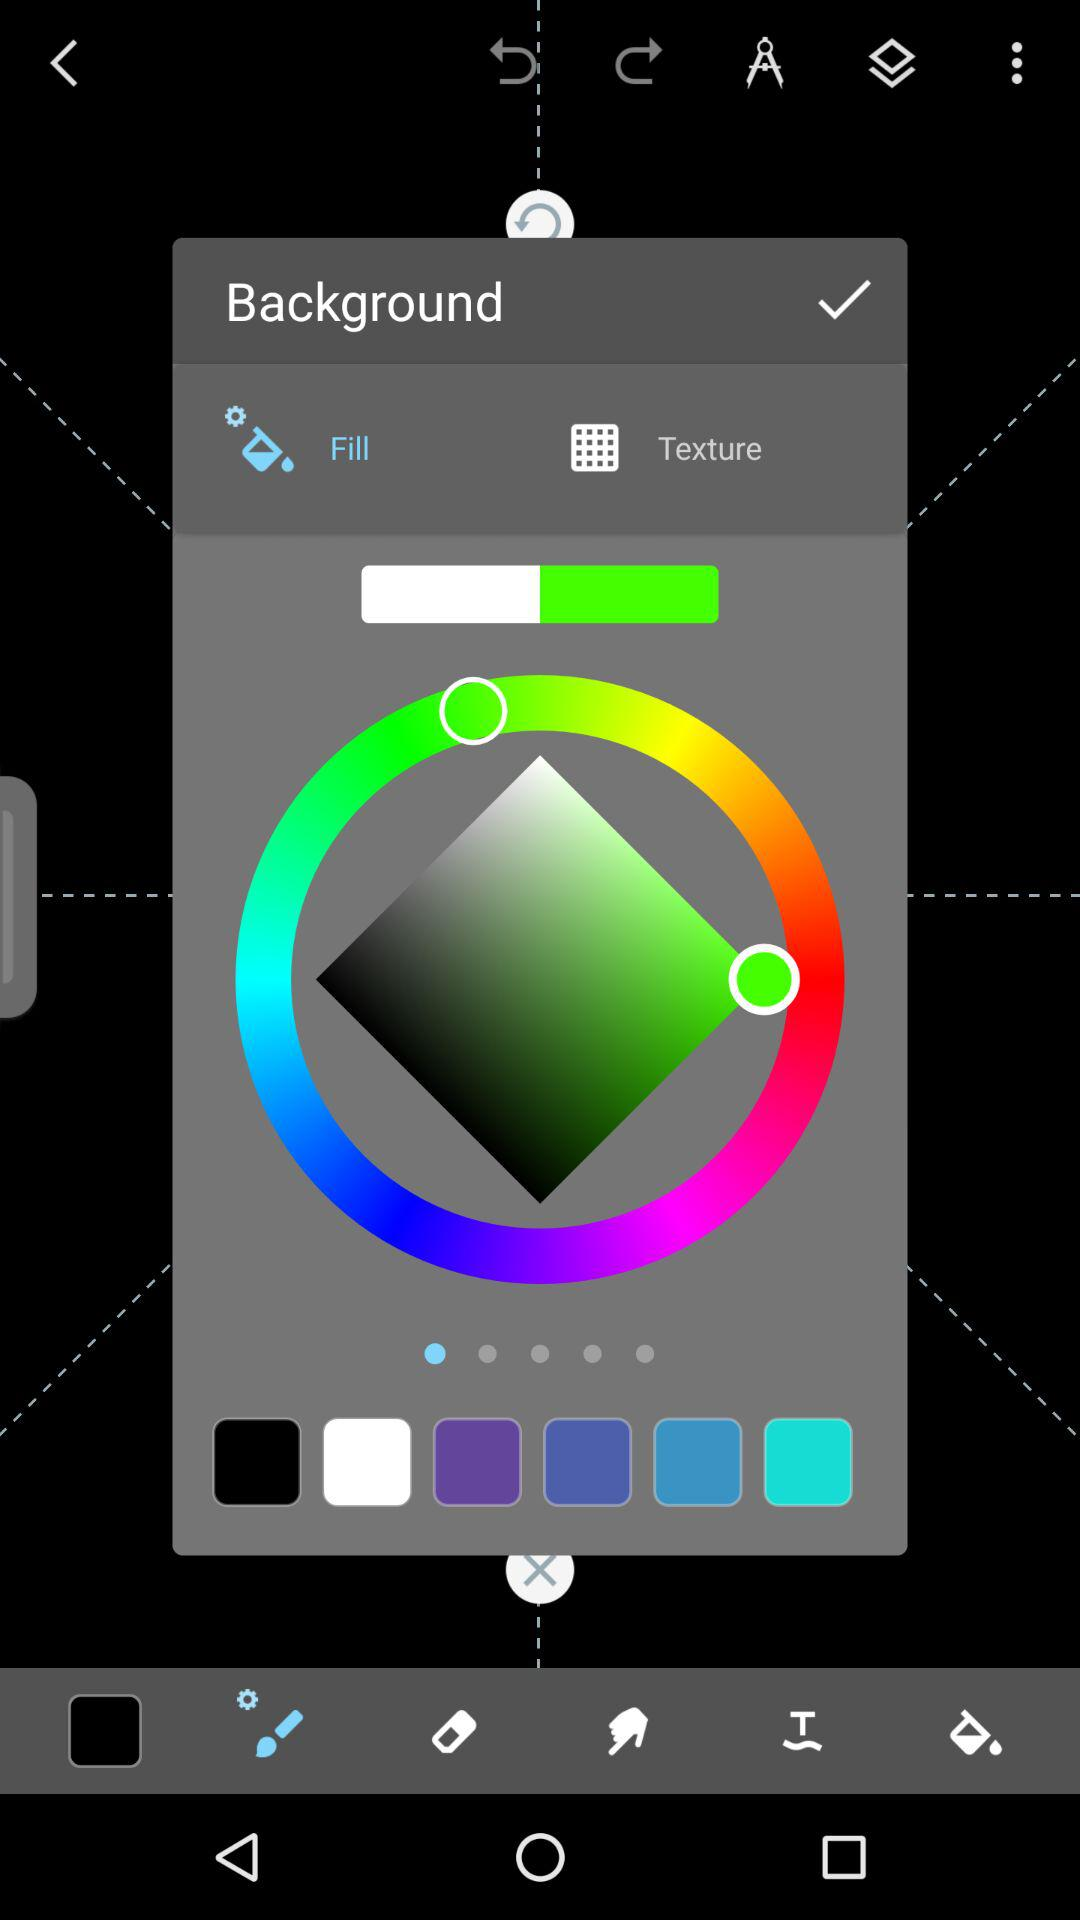Which tab is currently selected? The currently selected tab is "Fill". 